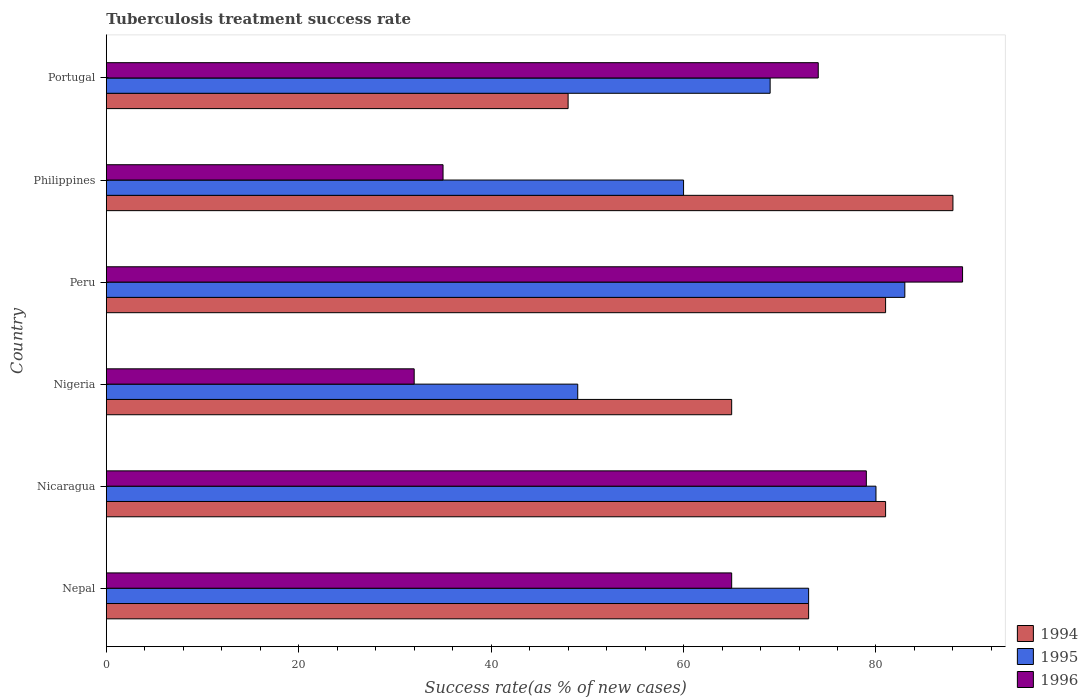How many groups of bars are there?
Offer a very short reply. 6. How many bars are there on the 3rd tick from the top?
Provide a succinct answer. 3. How many bars are there on the 1st tick from the bottom?
Your answer should be compact. 3. What is the label of the 6th group of bars from the top?
Make the answer very short. Nepal. What is the tuberculosis treatment success rate in 1996 in Peru?
Keep it short and to the point. 89. Across all countries, what is the maximum tuberculosis treatment success rate in 1996?
Your answer should be very brief. 89. What is the total tuberculosis treatment success rate in 1996 in the graph?
Your answer should be compact. 374. What is the difference between the tuberculosis treatment success rate in 1994 in Peru and the tuberculosis treatment success rate in 1996 in Portugal?
Keep it short and to the point. 7. What is the average tuberculosis treatment success rate in 1995 per country?
Your response must be concise. 69. What is the difference between the tuberculosis treatment success rate in 1995 and tuberculosis treatment success rate in 1994 in Nigeria?
Keep it short and to the point. -16. In how many countries, is the tuberculosis treatment success rate in 1996 greater than 84 %?
Give a very brief answer. 1. What is the ratio of the tuberculosis treatment success rate in 1996 in Nigeria to that in Peru?
Provide a short and direct response. 0.36. Is the tuberculosis treatment success rate in 1996 in Nicaragua less than that in Portugal?
Offer a terse response. No. Is the difference between the tuberculosis treatment success rate in 1995 in Nigeria and Peru greater than the difference between the tuberculosis treatment success rate in 1994 in Nigeria and Peru?
Your answer should be compact. No. What does the 1st bar from the top in Nigeria represents?
Ensure brevity in your answer.  1996. What does the 1st bar from the bottom in Portugal represents?
Provide a short and direct response. 1994. What is the difference between two consecutive major ticks on the X-axis?
Provide a succinct answer. 20. Does the graph contain any zero values?
Ensure brevity in your answer.  No. Does the graph contain grids?
Provide a succinct answer. No. Where does the legend appear in the graph?
Give a very brief answer. Bottom right. How many legend labels are there?
Your answer should be compact. 3. What is the title of the graph?
Make the answer very short. Tuberculosis treatment success rate. What is the label or title of the X-axis?
Your answer should be very brief. Success rate(as % of new cases). What is the label or title of the Y-axis?
Offer a very short reply. Country. What is the Success rate(as % of new cases) of 1996 in Nicaragua?
Ensure brevity in your answer.  79. What is the Success rate(as % of new cases) in 1994 in Peru?
Keep it short and to the point. 81. What is the Success rate(as % of new cases) in 1995 in Peru?
Offer a very short reply. 83. What is the Success rate(as % of new cases) in 1996 in Peru?
Provide a short and direct response. 89. What is the Success rate(as % of new cases) in 1996 in Portugal?
Keep it short and to the point. 74. Across all countries, what is the maximum Success rate(as % of new cases) in 1994?
Offer a terse response. 88. Across all countries, what is the maximum Success rate(as % of new cases) of 1995?
Your answer should be very brief. 83. Across all countries, what is the maximum Success rate(as % of new cases) of 1996?
Ensure brevity in your answer.  89. Across all countries, what is the minimum Success rate(as % of new cases) in 1995?
Keep it short and to the point. 49. Across all countries, what is the minimum Success rate(as % of new cases) in 1996?
Make the answer very short. 32. What is the total Success rate(as % of new cases) of 1994 in the graph?
Your answer should be compact. 436. What is the total Success rate(as % of new cases) in 1995 in the graph?
Provide a succinct answer. 414. What is the total Success rate(as % of new cases) of 1996 in the graph?
Your answer should be compact. 374. What is the difference between the Success rate(as % of new cases) in 1994 in Nepal and that in Nicaragua?
Make the answer very short. -8. What is the difference between the Success rate(as % of new cases) of 1996 in Nepal and that in Nicaragua?
Your response must be concise. -14. What is the difference between the Success rate(as % of new cases) of 1996 in Nepal and that in Nigeria?
Offer a very short reply. 33. What is the difference between the Success rate(as % of new cases) in 1996 in Nepal and that in Peru?
Provide a short and direct response. -24. What is the difference between the Success rate(as % of new cases) in 1994 in Nepal and that in Philippines?
Make the answer very short. -15. What is the difference between the Success rate(as % of new cases) in 1995 in Nepal and that in Philippines?
Provide a short and direct response. 13. What is the difference between the Success rate(as % of new cases) in 1996 in Nepal and that in Philippines?
Offer a very short reply. 30. What is the difference between the Success rate(as % of new cases) in 1995 in Nepal and that in Portugal?
Your answer should be compact. 4. What is the difference between the Success rate(as % of new cases) in 1996 in Nepal and that in Portugal?
Keep it short and to the point. -9. What is the difference between the Success rate(as % of new cases) of 1994 in Nicaragua and that in Nigeria?
Your answer should be compact. 16. What is the difference between the Success rate(as % of new cases) in 1996 in Nicaragua and that in Nigeria?
Your answer should be compact. 47. What is the difference between the Success rate(as % of new cases) of 1994 in Nicaragua and that in Peru?
Ensure brevity in your answer.  0. What is the difference between the Success rate(as % of new cases) in 1994 in Nicaragua and that in Philippines?
Your answer should be compact. -7. What is the difference between the Success rate(as % of new cases) in 1996 in Nicaragua and that in Philippines?
Ensure brevity in your answer.  44. What is the difference between the Success rate(as % of new cases) of 1994 in Nicaragua and that in Portugal?
Make the answer very short. 33. What is the difference between the Success rate(as % of new cases) of 1995 in Nicaragua and that in Portugal?
Your response must be concise. 11. What is the difference between the Success rate(as % of new cases) in 1995 in Nigeria and that in Peru?
Offer a very short reply. -34. What is the difference between the Success rate(as % of new cases) of 1996 in Nigeria and that in Peru?
Your answer should be compact. -57. What is the difference between the Success rate(as % of new cases) in 1994 in Nigeria and that in Philippines?
Make the answer very short. -23. What is the difference between the Success rate(as % of new cases) in 1995 in Nigeria and that in Philippines?
Your response must be concise. -11. What is the difference between the Success rate(as % of new cases) of 1996 in Nigeria and that in Philippines?
Your answer should be compact. -3. What is the difference between the Success rate(as % of new cases) in 1996 in Nigeria and that in Portugal?
Make the answer very short. -42. What is the difference between the Success rate(as % of new cases) of 1994 in Peru and that in Philippines?
Your answer should be compact. -7. What is the difference between the Success rate(as % of new cases) of 1995 in Peru and that in Philippines?
Make the answer very short. 23. What is the difference between the Success rate(as % of new cases) of 1995 in Peru and that in Portugal?
Give a very brief answer. 14. What is the difference between the Success rate(as % of new cases) in 1996 in Peru and that in Portugal?
Your answer should be compact. 15. What is the difference between the Success rate(as % of new cases) of 1996 in Philippines and that in Portugal?
Your response must be concise. -39. What is the difference between the Success rate(as % of new cases) of 1995 in Nepal and the Success rate(as % of new cases) of 1996 in Nicaragua?
Offer a terse response. -6. What is the difference between the Success rate(as % of new cases) in 1994 in Nepal and the Success rate(as % of new cases) in 1996 in Nigeria?
Your answer should be compact. 41. What is the difference between the Success rate(as % of new cases) in 1995 in Nepal and the Success rate(as % of new cases) in 1996 in Nigeria?
Keep it short and to the point. 41. What is the difference between the Success rate(as % of new cases) of 1994 in Nepal and the Success rate(as % of new cases) of 1995 in Peru?
Make the answer very short. -10. What is the difference between the Success rate(as % of new cases) of 1994 in Nepal and the Success rate(as % of new cases) of 1996 in Peru?
Make the answer very short. -16. What is the difference between the Success rate(as % of new cases) in 1995 in Nepal and the Success rate(as % of new cases) in 1996 in Peru?
Your answer should be compact. -16. What is the difference between the Success rate(as % of new cases) in 1995 in Nepal and the Success rate(as % of new cases) in 1996 in Philippines?
Your response must be concise. 38. What is the difference between the Success rate(as % of new cases) of 1994 in Nepal and the Success rate(as % of new cases) of 1995 in Portugal?
Provide a short and direct response. 4. What is the difference between the Success rate(as % of new cases) of 1994 in Nepal and the Success rate(as % of new cases) of 1996 in Portugal?
Keep it short and to the point. -1. What is the difference between the Success rate(as % of new cases) in 1994 in Nicaragua and the Success rate(as % of new cases) in 1995 in Nigeria?
Provide a short and direct response. 32. What is the difference between the Success rate(as % of new cases) in 1994 in Nicaragua and the Success rate(as % of new cases) in 1996 in Nigeria?
Provide a succinct answer. 49. What is the difference between the Success rate(as % of new cases) in 1994 in Nicaragua and the Success rate(as % of new cases) in 1995 in Peru?
Your answer should be compact. -2. What is the difference between the Success rate(as % of new cases) in 1995 in Nicaragua and the Success rate(as % of new cases) in 1996 in Peru?
Your answer should be compact. -9. What is the difference between the Success rate(as % of new cases) of 1994 in Nicaragua and the Success rate(as % of new cases) of 1995 in Philippines?
Offer a terse response. 21. What is the difference between the Success rate(as % of new cases) in 1994 in Nicaragua and the Success rate(as % of new cases) in 1996 in Philippines?
Your answer should be very brief. 46. What is the difference between the Success rate(as % of new cases) of 1995 in Nicaragua and the Success rate(as % of new cases) of 1996 in Philippines?
Keep it short and to the point. 45. What is the difference between the Success rate(as % of new cases) in 1994 in Nicaragua and the Success rate(as % of new cases) in 1995 in Portugal?
Offer a very short reply. 12. What is the difference between the Success rate(as % of new cases) in 1994 in Nigeria and the Success rate(as % of new cases) in 1996 in Peru?
Give a very brief answer. -24. What is the difference between the Success rate(as % of new cases) in 1995 in Nigeria and the Success rate(as % of new cases) in 1996 in Peru?
Provide a succinct answer. -40. What is the difference between the Success rate(as % of new cases) in 1995 in Nigeria and the Success rate(as % of new cases) in 1996 in Philippines?
Make the answer very short. 14. What is the difference between the Success rate(as % of new cases) of 1994 in Nigeria and the Success rate(as % of new cases) of 1995 in Portugal?
Provide a succinct answer. -4. What is the difference between the Success rate(as % of new cases) of 1994 in Nigeria and the Success rate(as % of new cases) of 1996 in Portugal?
Give a very brief answer. -9. What is the difference between the Success rate(as % of new cases) of 1994 in Peru and the Success rate(as % of new cases) of 1995 in Philippines?
Ensure brevity in your answer.  21. What is the difference between the Success rate(as % of new cases) in 1994 in Peru and the Success rate(as % of new cases) in 1996 in Philippines?
Your answer should be very brief. 46. What is the difference between the Success rate(as % of new cases) of 1994 in Peru and the Success rate(as % of new cases) of 1996 in Portugal?
Offer a very short reply. 7. What is the difference between the Success rate(as % of new cases) of 1995 in Peru and the Success rate(as % of new cases) of 1996 in Portugal?
Offer a very short reply. 9. What is the difference between the Success rate(as % of new cases) of 1995 in Philippines and the Success rate(as % of new cases) of 1996 in Portugal?
Your answer should be very brief. -14. What is the average Success rate(as % of new cases) in 1994 per country?
Offer a terse response. 72.67. What is the average Success rate(as % of new cases) of 1996 per country?
Give a very brief answer. 62.33. What is the difference between the Success rate(as % of new cases) in 1994 and Success rate(as % of new cases) in 1995 in Nepal?
Offer a terse response. 0. What is the difference between the Success rate(as % of new cases) in 1994 and Success rate(as % of new cases) in 1995 in Nicaragua?
Keep it short and to the point. 1. What is the difference between the Success rate(as % of new cases) of 1994 and Success rate(as % of new cases) of 1996 in Nicaragua?
Make the answer very short. 2. What is the difference between the Success rate(as % of new cases) of 1994 and Success rate(as % of new cases) of 1995 in Nigeria?
Provide a short and direct response. 16. What is the difference between the Success rate(as % of new cases) of 1995 and Success rate(as % of new cases) of 1996 in Peru?
Make the answer very short. -6. What is the difference between the Success rate(as % of new cases) in 1994 and Success rate(as % of new cases) in 1996 in Philippines?
Offer a very short reply. 53. What is the difference between the Success rate(as % of new cases) of 1994 and Success rate(as % of new cases) of 1996 in Portugal?
Offer a terse response. -26. What is the ratio of the Success rate(as % of new cases) in 1994 in Nepal to that in Nicaragua?
Ensure brevity in your answer.  0.9. What is the ratio of the Success rate(as % of new cases) in 1995 in Nepal to that in Nicaragua?
Your response must be concise. 0.91. What is the ratio of the Success rate(as % of new cases) in 1996 in Nepal to that in Nicaragua?
Your answer should be very brief. 0.82. What is the ratio of the Success rate(as % of new cases) of 1994 in Nepal to that in Nigeria?
Give a very brief answer. 1.12. What is the ratio of the Success rate(as % of new cases) of 1995 in Nepal to that in Nigeria?
Make the answer very short. 1.49. What is the ratio of the Success rate(as % of new cases) in 1996 in Nepal to that in Nigeria?
Your answer should be very brief. 2.03. What is the ratio of the Success rate(as % of new cases) in 1994 in Nepal to that in Peru?
Offer a very short reply. 0.9. What is the ratio of the Success rate(as % of new cases) in 1995 in Nepal to that in Peru?
Your response must be concise. 0.88. What is the ratio of the Success rate(as % of new cases) of 1996 in Nepal to that in Peru?
Provide a short and direct response. 0.73. What is the ratio of the Success rate(as % of new cases) in 1994 in Nepal to that in Philippines?
Your answer should be compact. 0.83. What is the ratio of the Success rate(as % of new cases) in 1995 in Nepal to that in Philippines?
Give a very brief answer. 1.22. What is the ratio of the Success rate(as % of new cases) of 1996 in Nepal to that in Philippines?
Keep it short and to the point. 1.86. What is the ratio of the Success rate(as % of new cases) of 1994 in Nepal to that in Portugal?
Offer a very short reply. 1.52. What is the ratio of the Success rate(as % of new cases) in 1995 in Nepal to that in Portugal?
Offer a terse response. 1.06. What is the ratio of the Success rate(as % of new cases) of 1996 in Nepal to that in Portugal?
Make the answer very short. 0.88. What is the ratio of the Success rate(as % of new cases) of 1994 in Nicaragua to that in Nigeria?
Offer a terse response. 1.25. What is the ratio of the Success rate(as % of new cases) of 1995 in Nicaragua to that in Nigeria?
Your response must be concise. 1.63. What is the ratio of the Success rate(as % of new cases) of 1996 in Nicaragua to that in Nigeria?
Provide a succinct answer. 2.47. What is the ratio of the Success rate(as % of new cases) of 1995 in Nicaragua to that in Peru?
Provide a succinct answer. 0.96. What is the ratio of the Success rate(as % of new cases) of 1996 in Nicaragua to that in Peru?
Provide a succinct answer. 0.89. What is the ratio of the Success rate(as % of new cases) of 1994 in Nicaragua to that in Philippines?
Your answer should be very brief. 0.92. What is the ratio of the Success rate(as % of new cases) in 1996 in Nicaragua to that in Philippines?
Provide a short and direct response. 2.26. What is the ratio of the Success rate(as % of new cases) in 1994 in Nicaragua to that in Portugal?
Keep it short and to the point. 1.69. What is the ratio of the Success rate(as % of new cases) in 1995 in Nicaragua to that in Portugal?
Your answer should be very brief. 1.16. What is the ratio of the Success rate(as % of new cases) of 1996 in Nicaragua to that in Portugal?
Offer a terse response. 1.07. What is the ratio of the Success rate(as % of new cases) of 1994 in Nigeria to that in Peru?
Your response must be concise. 0.8. What is the ratio of the Success rate(as % of new cases) of 1995 in Nigeria to that in Peru?
Provide a short and direct response. 0.59. What is the ratio of the Success rate(as % of new cases) of 1996 in Nigeria to that in Peru?
Your response must be concise. 0.36. What is the ratio of the Success rate(as % of new cases) in 1994 in Nigeria to that in Philippines?
Ensure brevity in your answer.  0.74. What is the ratio of the Success rate(as % of new cases) in 1995 in Nigeria to that in Philippines?
Provide a succinct answer. 0.82. What is the ratio of the Success rate(as % of new cases) of 1996 in Nigeria to that in Philippines?
Ensure brevity in your answer.  0.91. What is the ratio of the Success rate(as % of new cases) in 1994 in Nigeria to that in Portugal?
Keep it short and to the point. 1.35. What is the ratio of the Success rate(as % of new cases) in 1995 in Nigeria to that in Portugal?
Provide a succinct answer. 0.71. What is the ratio of the Success rate(as % of new cases) in 1996 in Nigeria to that in Portugal?
Offer a very short reply. 0.43. What is the ratio of the Success rate(as % of new cases) in 1994 in Peru to that in Philippines?
Offer a very short reply. 0.92. What is the ratio of the Success rate(as % of new cases) in 1995 in Peru to that in Philippines?
Make the answer very short. 1.38. What is the ratio of the Success rate(as % of new cases) of 1996 in Peru to that in Philippines?
Ensure brevity in your answer.  2.54. What is the ratio of the Success rate(as % of new cases) in 1994 in Peru to that in Portugal?
Your answer should be very brief. 1.69. What is the ratio of the Success rate(as % of new cases) of 1995 in Peru to that in Portugal?
Provide a succinct answer. 1.2. What is the ratio of the Success rate(as % of new cases) in 1996 in Peru to that in Portugal?
Ensure brevity in your answer.  1.2. What is the ratio of the Success rate(as % of new cases) in 1994 in Philippines to that in Portugal?
Give a very brief answer. 1.83. What is the ratio of the Success rate(as % of new cases) of 1995 in Philippines to that in Portugal?
Your answer should be compact. 0.87. What is the ratio of the Success rate(as % of new cases) of 1996 in Philippines to that in Portugal?
Ensure brevity in your answer.  0.47. What is the difference between the highest and the second highest Success rate(as % of new cases) in 1994?
Your response must be concise. 7. What is the difference between the highest and the lowest Success rate(as % of new cases) in 1995?
Offer a terse response. 34. 